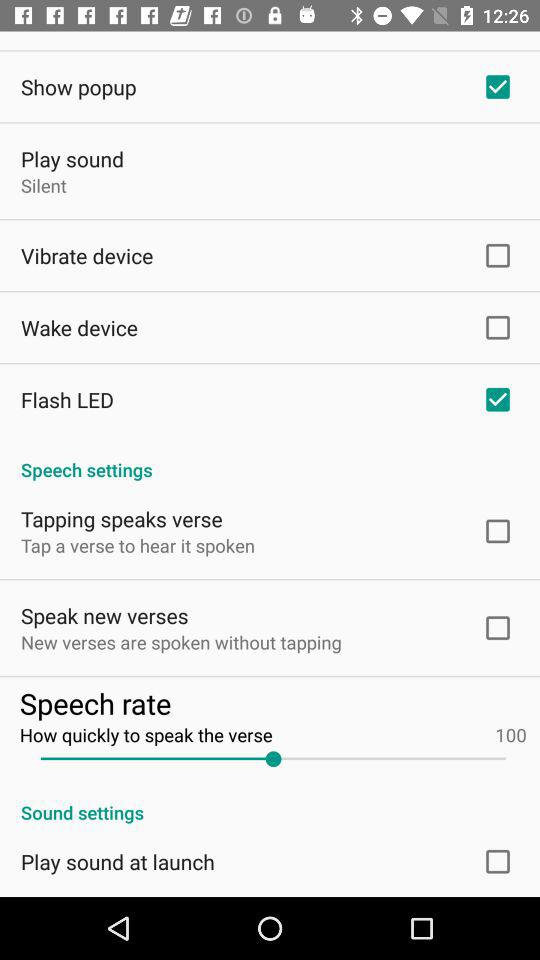What is the setting for the "Play sound"? The setting is "Silent". 